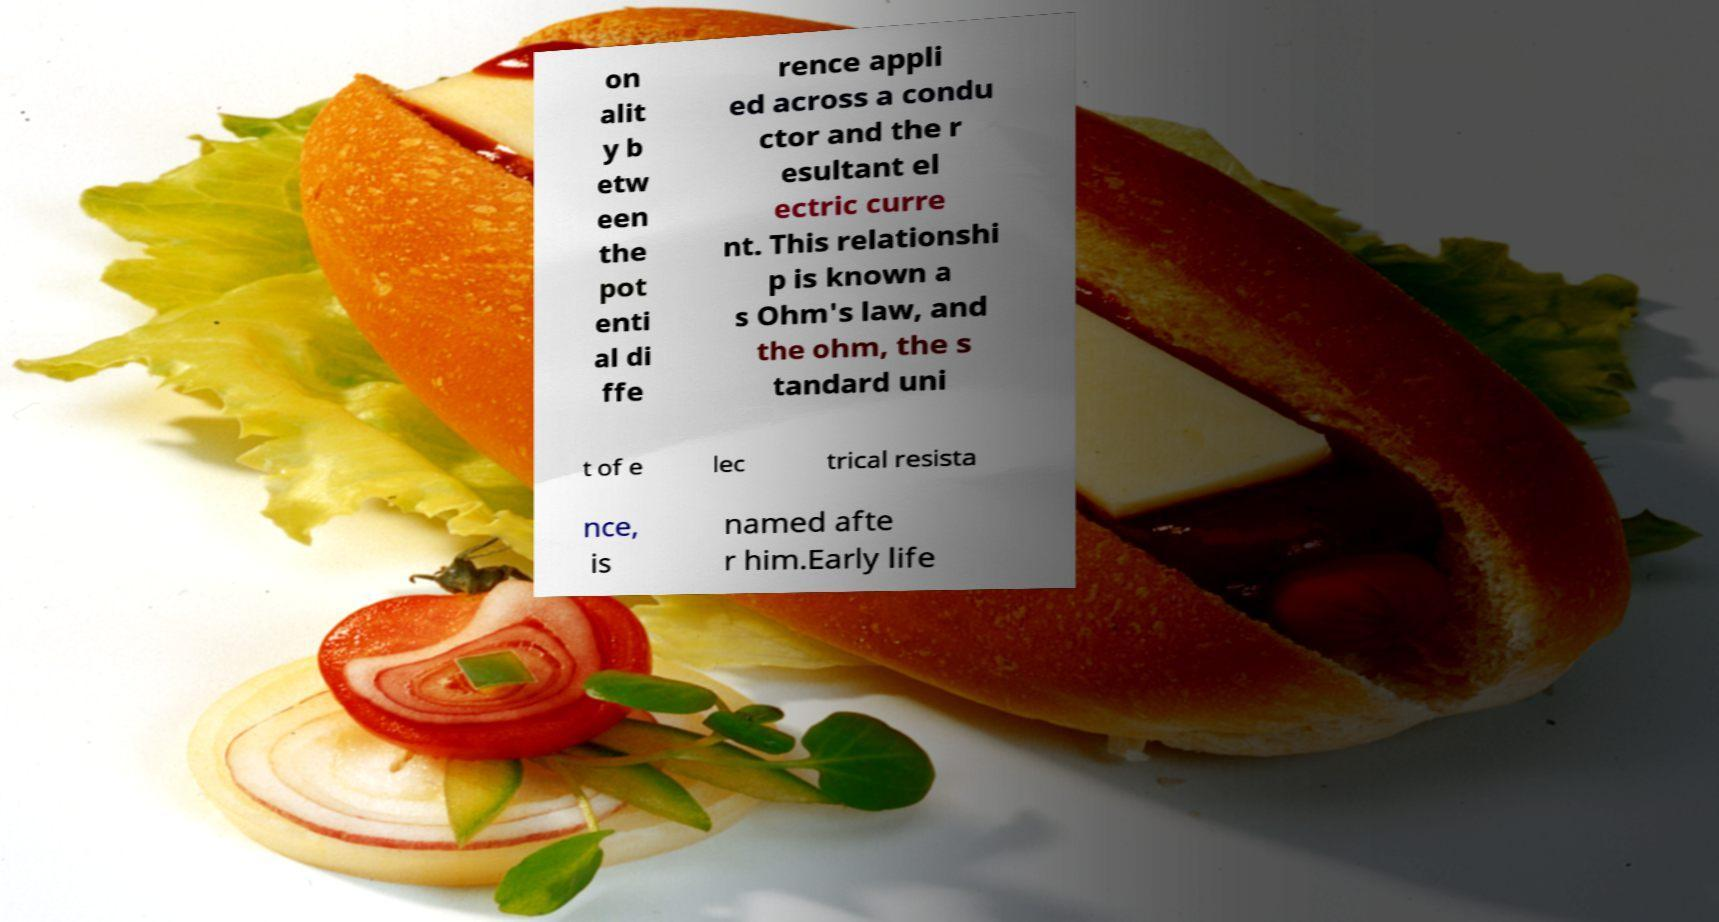Could you assist in decoding the text presented in this image and type it out clearly? on alit y b etw een the pot enti al di ffe rence appli ed across a condu ctor and the r esultant el ectric curre nt. This relationshi p is known a s Ohm's law, and the ohm, the s tandard uni t of e lec trical resista nce, is named afte r him.Early life 